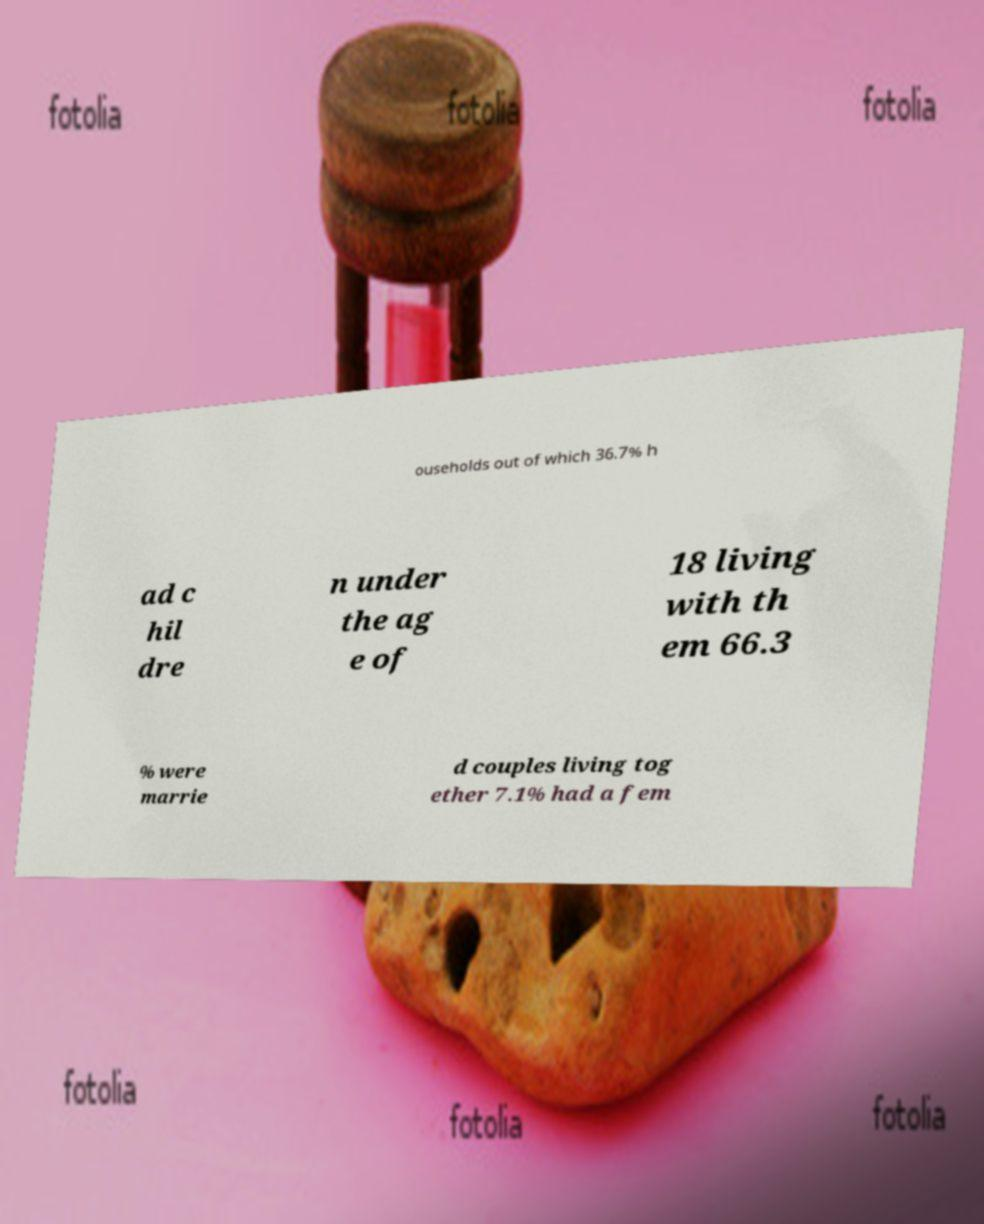Please identify and transcribe the text found in this image. ouseholds out of which 36.7% h ad c hil dre n under the ag e of 18 living with th em 66.3 % were marrie d couples living tog ether 7.1% had a fem 